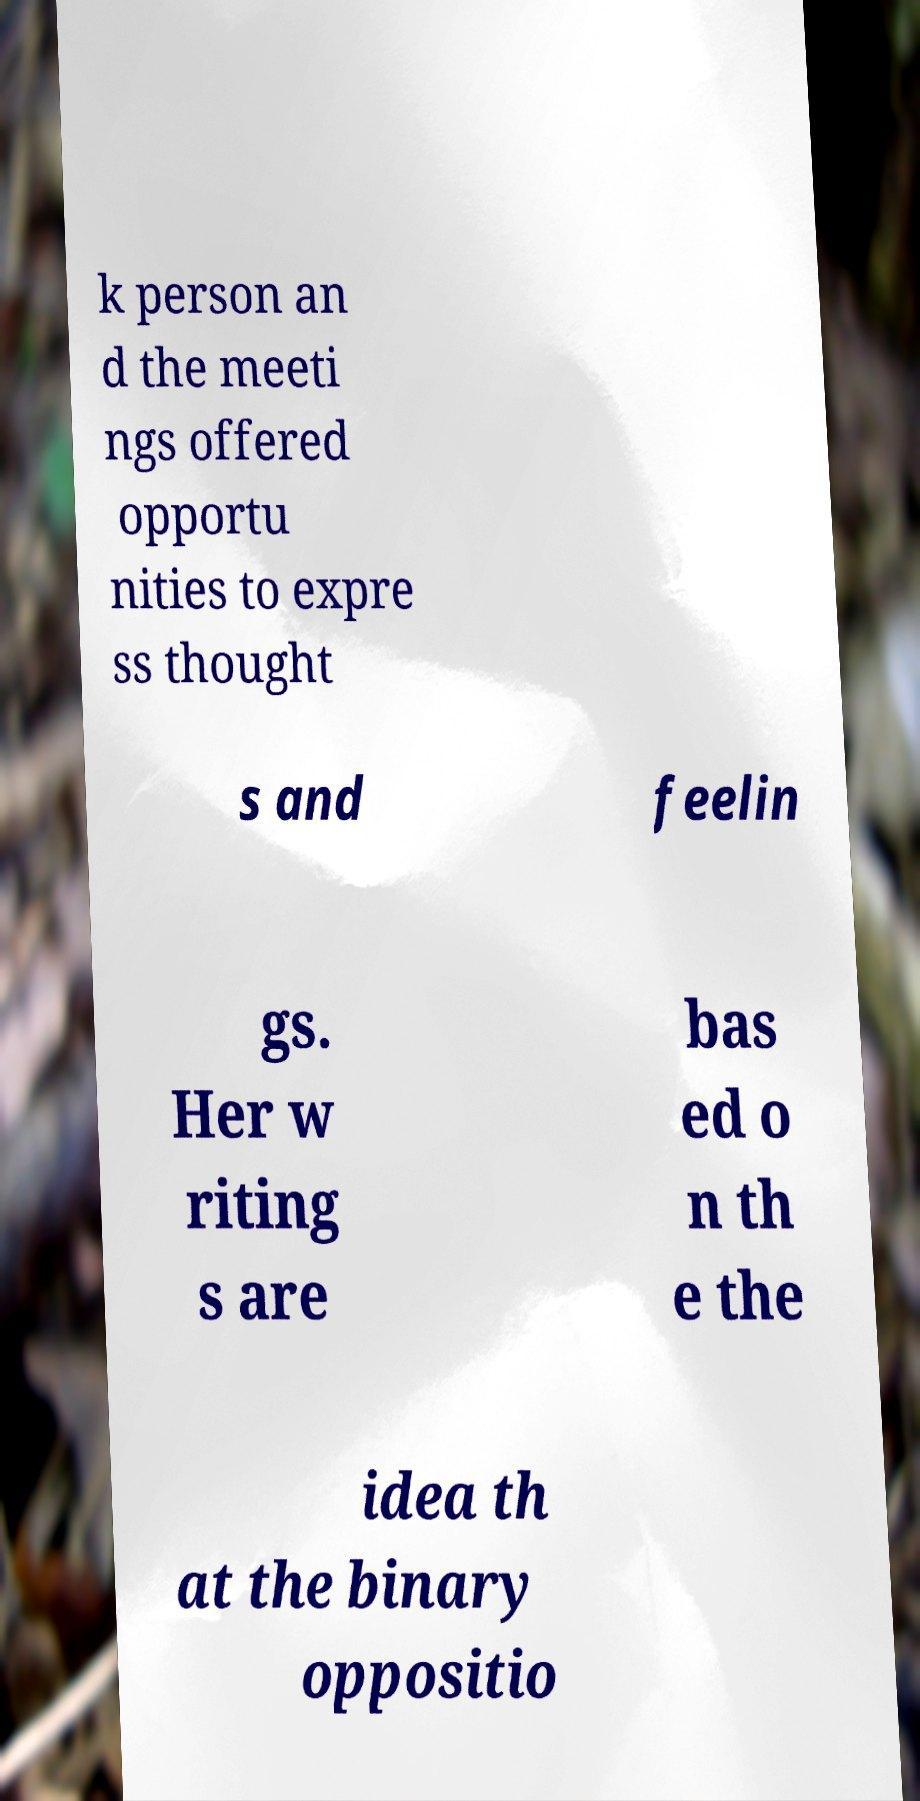Please identify and transcribe the text found in this image. k person an d the meeti ngs offered opportu nities to expre ss thought s and feelin gs. Her w riting s are bas ed o n th e the idea th at the binary oppositio 